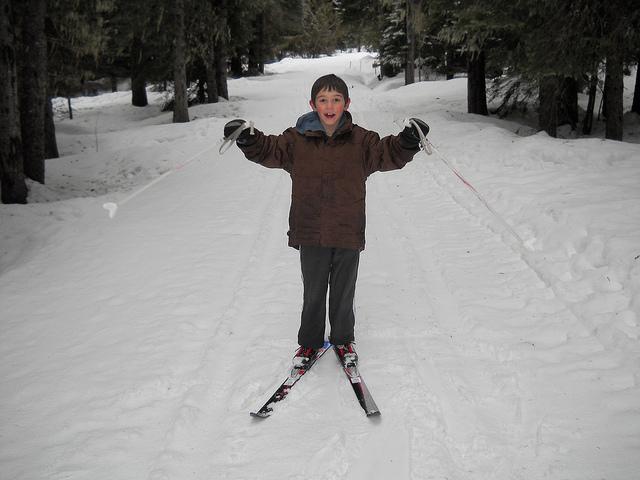How many ski poles are stuck into the snow?
Answer briefly. 0. Is the person moving?
Short answer required. No. What is the kid doing?
Write a very short answer. Skiing. 